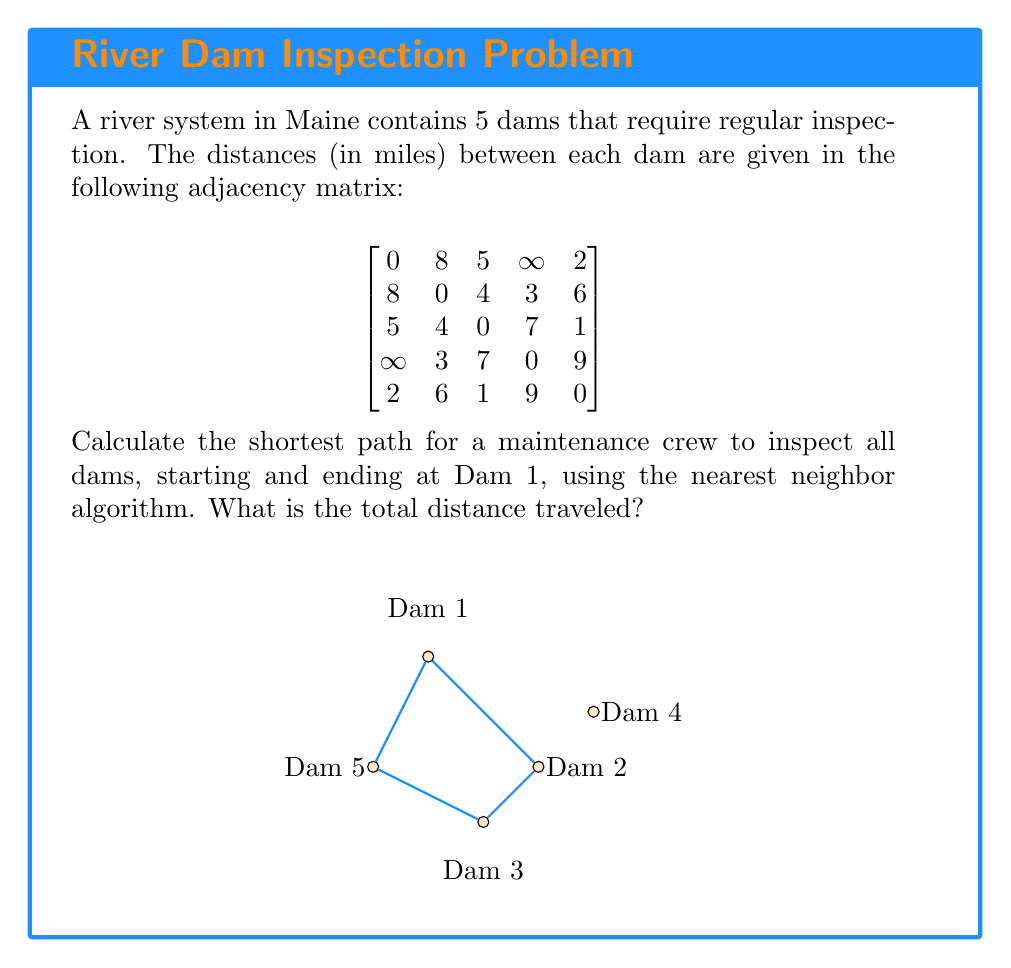Can you answer this question? To solve this problem using the nearest neighbor algorithm, we'll follow these steps:

1) Start at Dam 1.
2) Find the nearest unvisited dam and move to it.
3) Repeat step 2 until all dams have been visited.
4) Return to Dam 1.

Let's go through this process:

1) We start at Dam 1.

2) From Dam 1, the nearest dam is Dam 5 (2 miles away).
   Path so far: 1 -> 5, Distance: 2 miles

3) From Dam 5, the nearest unvisited dam is Dam 3 (1 mile away).
   Path so far: 1 -> 5 -> 3, Distance: 2 + 1 = 3 miles

4) From Dam 3, the nearest unvisited dam is Dam 2 (4 miles away).
   Path so far: 1 -> 5 -> 3 -> 2, Distance: 3 + 4 = 7 miles

5) From Dam 2, the only unvisited dam is Dam 4 (3 miles away).
   Path so far: 1 -> 5 -> 3 -> 2 -> 4, Distance: 7 + 3 = 10 miles

6) Finally, we return to Dam 1 from Dam 4 (∞ miles, but we can go through Dam 2).
   Final path: 1 -> 5 -> 3 -> 2 -> 4 -> 2 -> 1
   Total distance: 10 + 3 + 8 = 21 miles

Therefore, the shortest path using the nearest neighbor algorithm is:
Dam 1 -> Dam 5 -> Dam 3 -> Dam 2 -> Dam 4 -> Dam 2 -> Dam 1
Answer: The total distance traveled is 21 miles. 